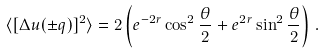Convert formula to latex. <formula><loc_0><loc_0><loc_500><loc_500>\langle [ \Delta u ( \pm { q } ) ] ^ { 2 } \rangle = 2 \left ( e ^ { - 2 r } \cos ^ { 2 } \frac { \theta } { 2 } + e ^ { 2 r } \sin ^ { 2 } \frac { \theta } { 2 } \right ) \, .</formula> 